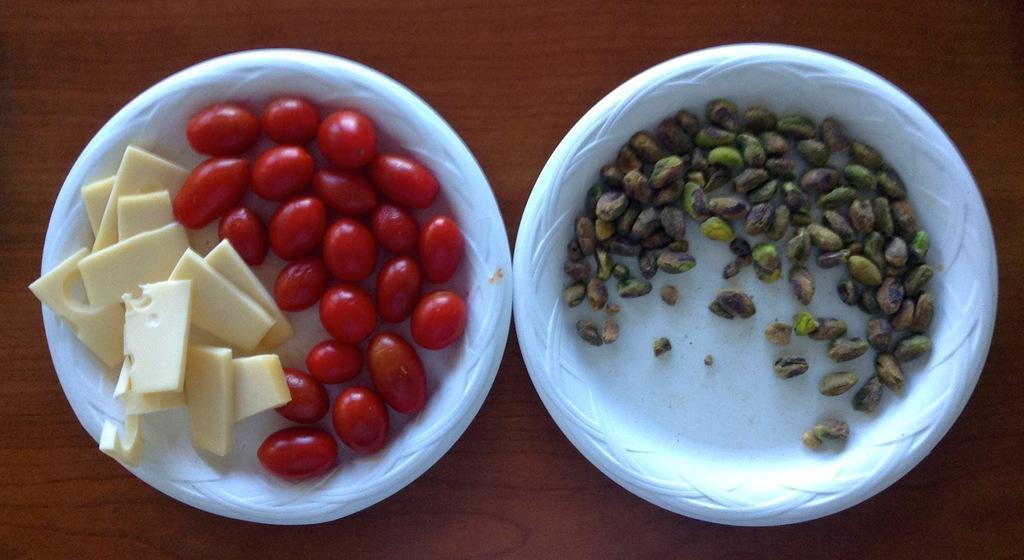Please provide a concise description of this image. In this image, we can see two white color plates, in that plates there are some food items kept. 